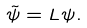Convert formula to latex. <formula><loc_0><loc_0><loc_500><loc_500>\tilde { \psi } = L \psi .</formula> 